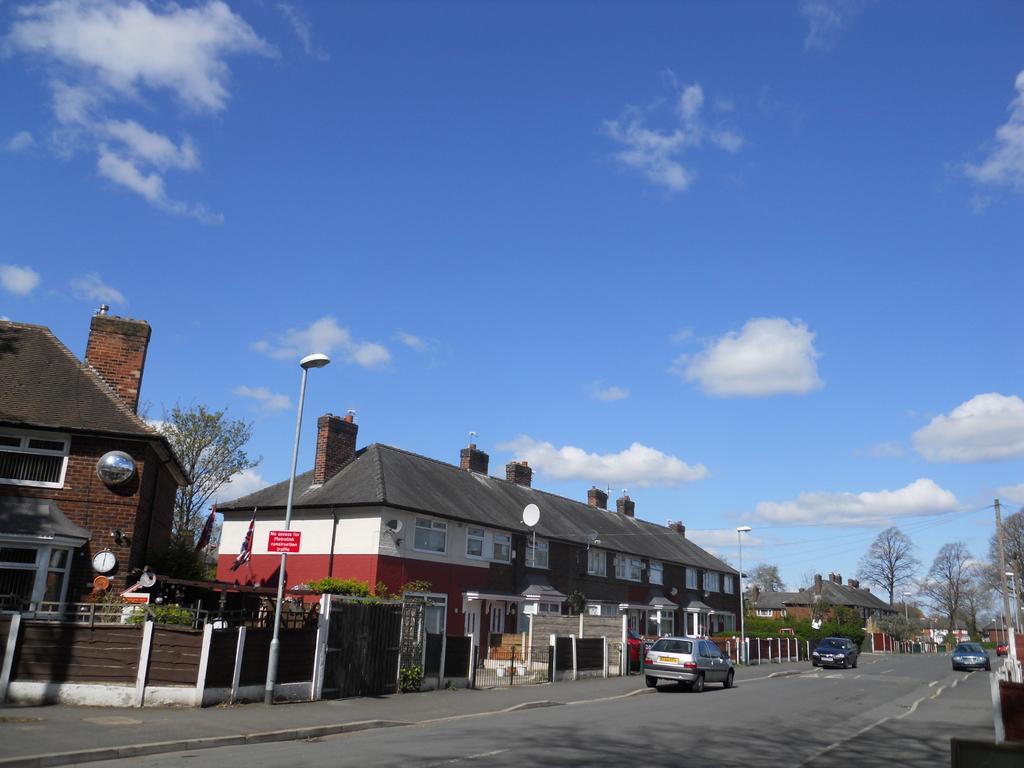Describe this image in one or two sentences. In this image we can see houses. There are light poles. There are trees. At the top of the image there is sky and clouds. At the bottom of the image there is road with vehicles. 